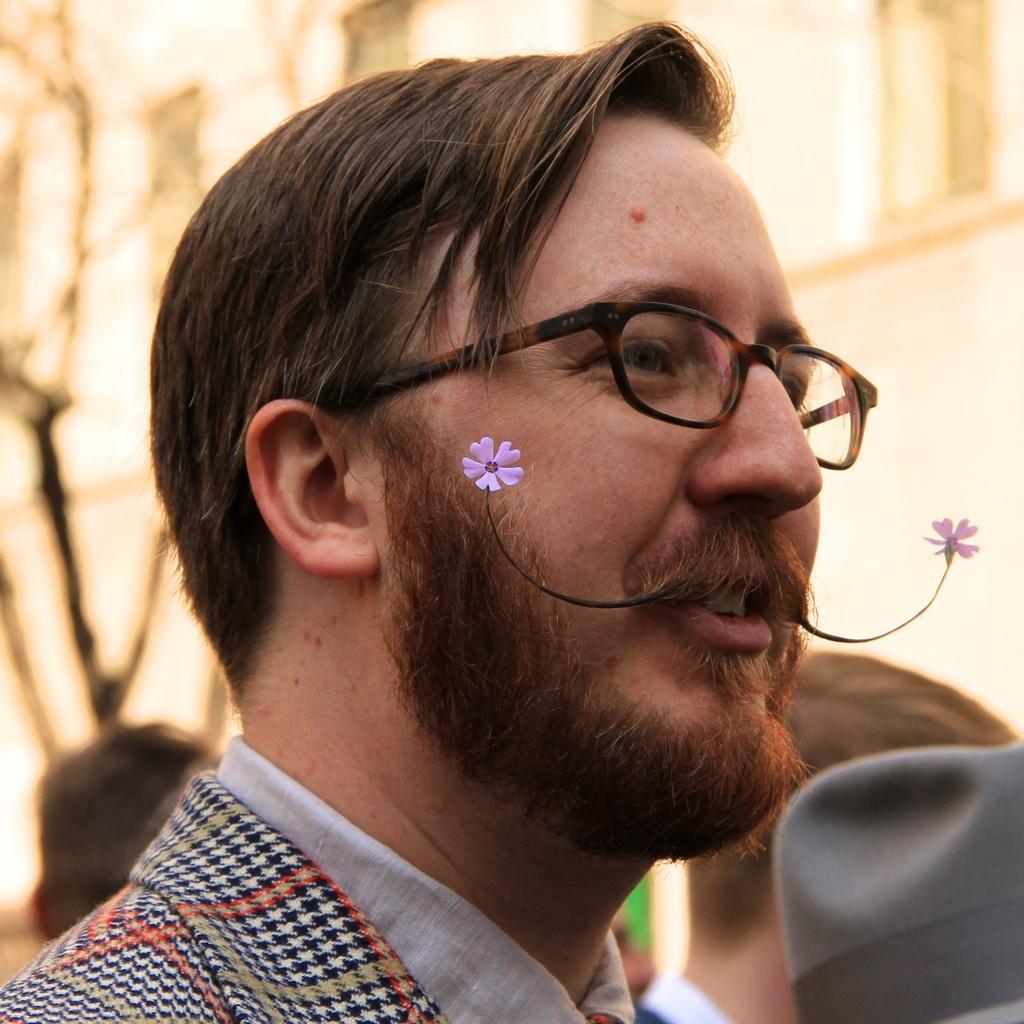Could you give a brief overview of what you see in this image? In this image we can see a man wearing the glasses and some flowers on his mustache. On the backside we can see some people. 